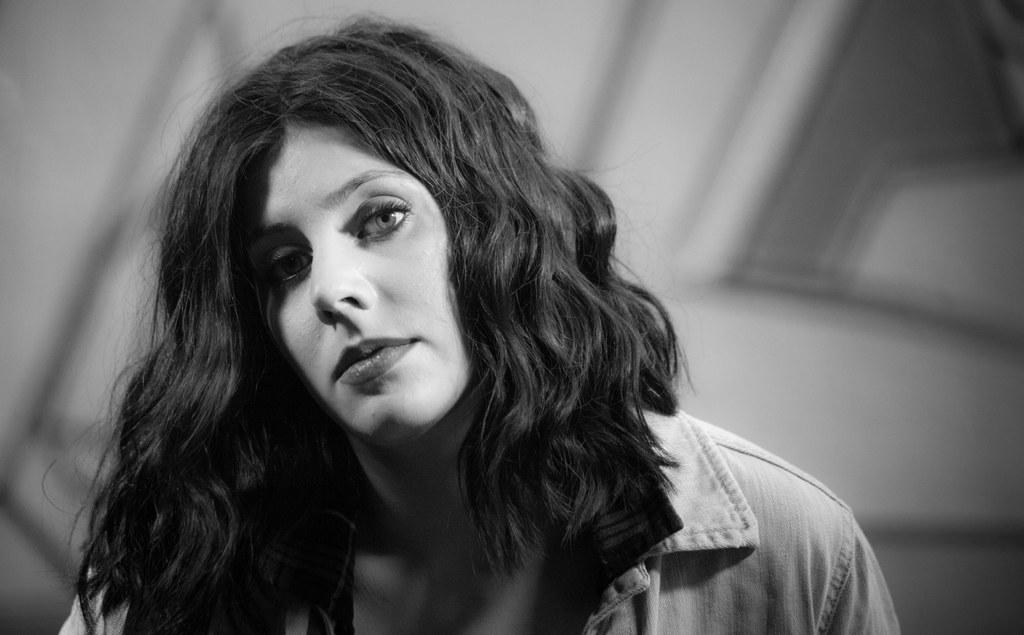What is the color scheme of the image? The image is black and white. Can you describe the person in the image? There is a lady in the image. What is the lady wearing in the image? The lady is wearing a shirt. What type of lead is the lady holding in the image? There is no lead present in the image. How does the lady use her toothbrush in the image? There is no toothbrush present in the image. 